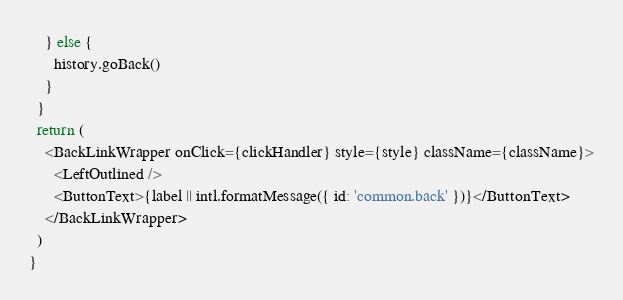<code> <loc_0><loc_0><loc_500><loc_500><_TypeScript_>    } else {
      history.goBack()
    }
  }
  return (
    <BackLinkWrapper onClick={clickHandler} style={style} className={className}>
      <LeftOutlined />
      <ButtonText>{label || intl.formatMessage({ id: 'common.back' })}</ButtonText>
    </BackLinkWrapper>
  )
}
</code> 